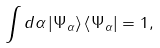<formula> <loc_0><loc_0><loc_500><loc_500>\int d \alpha \left | \Psi _ { \alpha } \right \rangle \left \langle \Psi _ { \alpha } \right | = 1 ,</formula> 